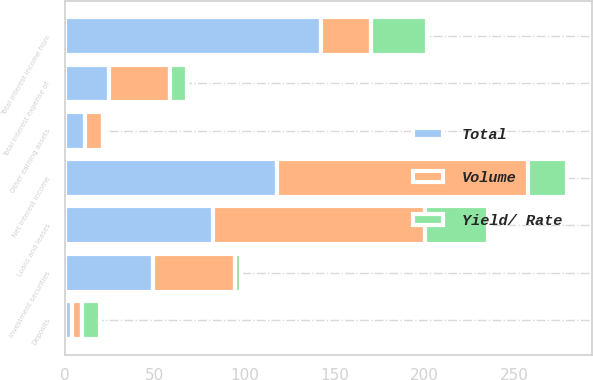Convert chart to OTSL. <chart><loc_0><loc_0><loc_500><loc_500><stacked_bar_chart><ecel><fcel>Loans and leases<fcel>Investment securities<fcel>Other earning assets<fcel>Total interest income from<fcel>Deposits<fcel>Total interest expense of<fcel>Net interest income<nl><fcel>Volume<fcel>117.6<fcel>45.8<fcel>10.4<fcel>27.85<fcel>5.6<fcel>34.1<fcel>139.7<nl><fcel>Yield/ Rate<fcel>35.1<fcel>3.2<fcel>0.7<fcel>31.2<fcel>9.9<fcel>9.6<fcel>21.6<nl><fcel>Total<fcel>82.5<fcel>49<fcel>11.1<fcel>142.6<fcel>4.3<fcel>24.5<fcel>118.1<nl></chart> 